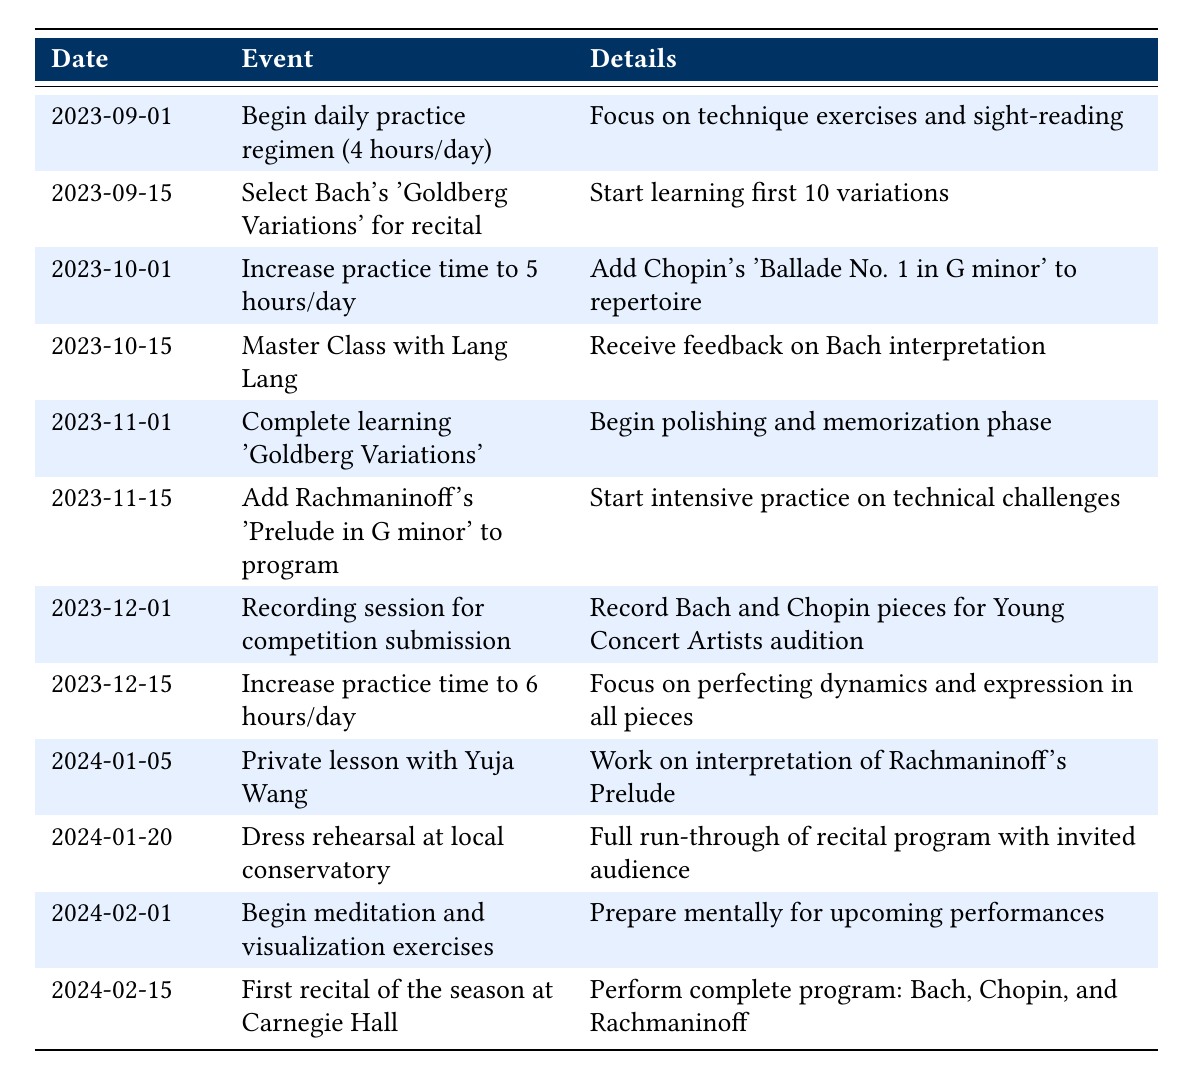What event is scheduled for October 15, 2023? The table lists the event scheduled for October 15, 2023, as "Master Class with Lang Lang."
Answer: Master Class with Lang Lang How many hours a day was the practice regimen increased to on October 1, 2023? According to the table, the daily practice time was increased to 5 hours on October 1, 2023.
Answer: 5 hours True or False: There are recording sessions scheduled before the first recital. The table shows that a recording session is scheduled on December 1, 2023, which is before the first recital on February 15, 2024. Therefore, the statement is true.
Answer: True What is the total practice time increase from September 1, 2023, to December 15, 2023? The practice time increased from 4 hours on September 1 to 6 hours on December 15. The difference is 6 - 4 = 2 hours.
Answer: 2 hours What major work was selected for the recital on September 15, 2023? The table indicates that Bach's 'Goldberg Variations' was selected for the recital on September 15, 2023.
Answer: Bach's 'Goldberg Variations' What is the sequence of events leading to the first recital on February 15, 2024? The sequence is as follows: selecting the 'Goldberg Variations' on September 15, mastering it by November 1, adding more pieces like Rachmaninoff's Prelude by November 15, recording sessions and increasing practice hours through December, and rehearsals and mental preparation in January before the recital.
Answer: Selection, mastery, additions, recording, rehearsal, recital How many lessons with notable pianists are scheduled before February 15, 2024? The table lists two lessons with notable pianists: one with Lang Lang on October 15, 2023, and another with Yuja Wang on January 5, 2024. Therefore, there are 2 lessons scheduled.
Answer: 2 lessons 